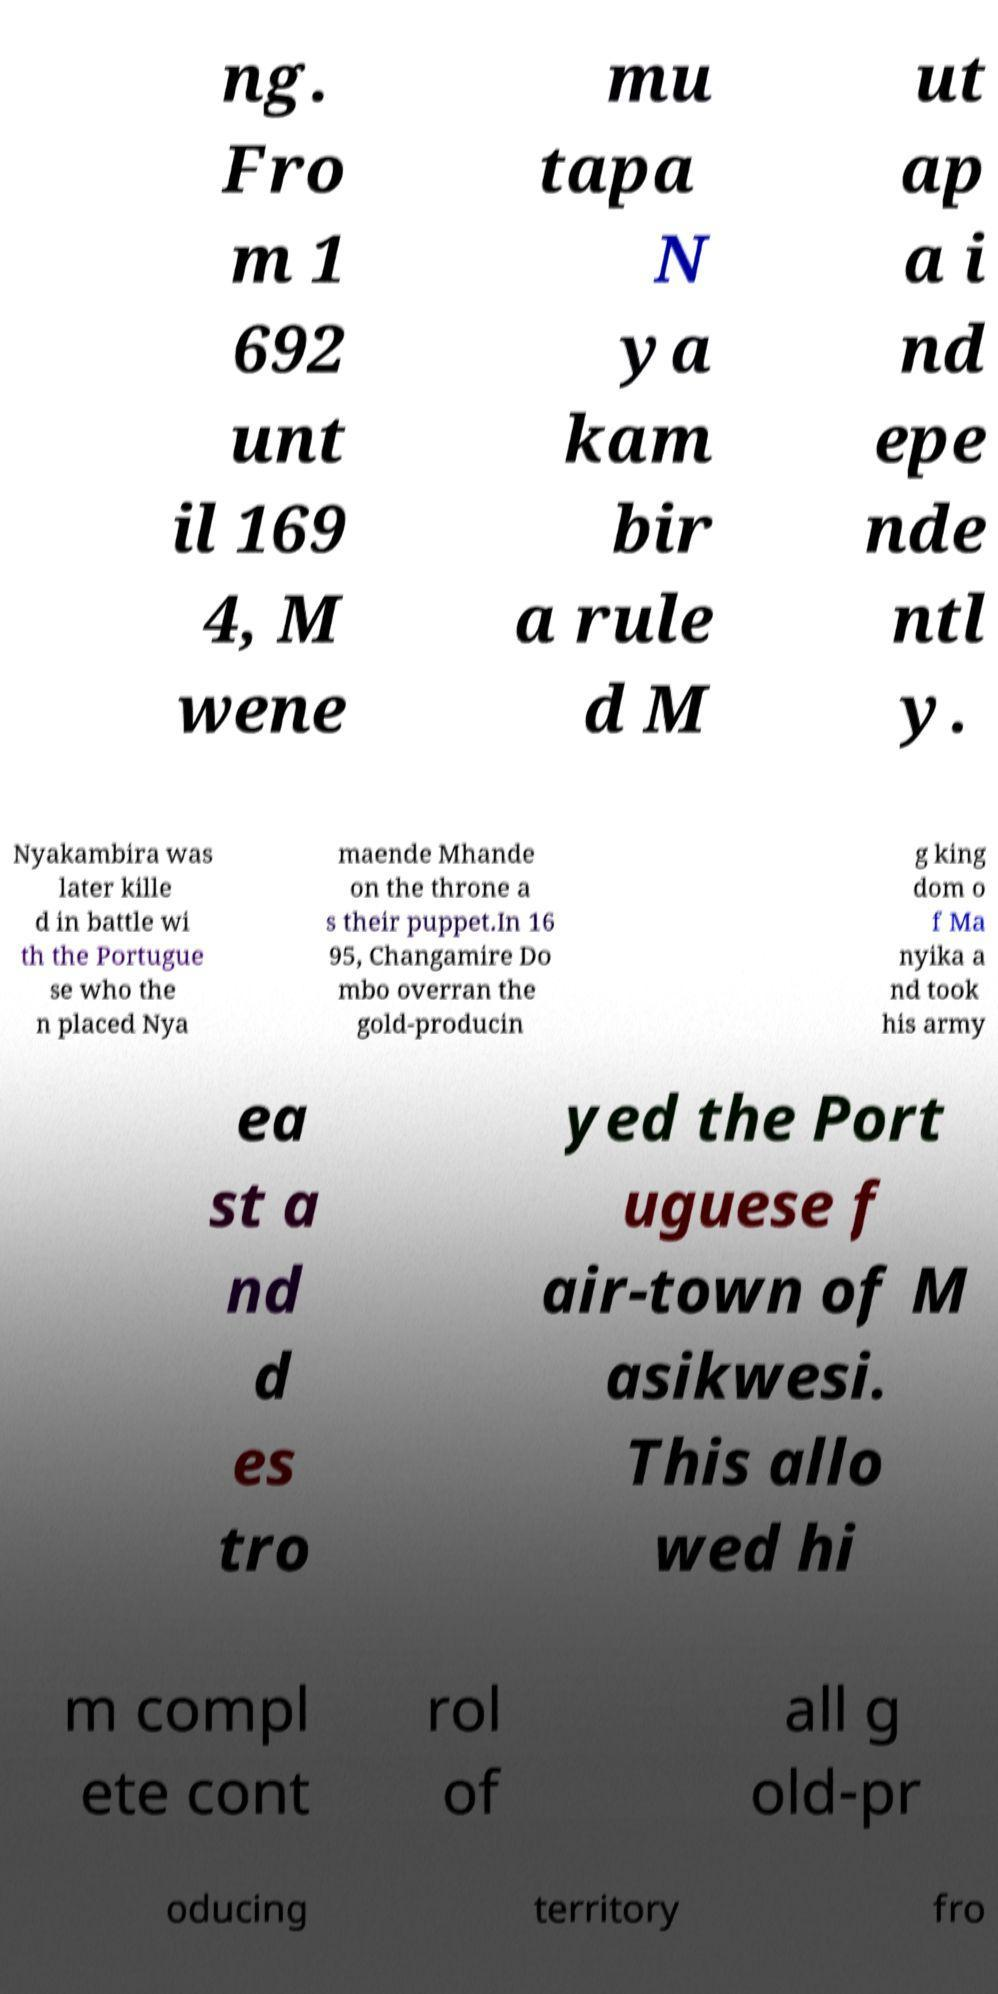Can you accurately transcribe the text from the provided image for me? ng. Fro m 1 692 unt il 169 4, M wene mu tapa N ya kam bir a rule d M ut ap a i nd epe nde ntl y. Nyakambira was later kille d in battle wi th the Portugue se who the n placed Nya maende Mhande on the throne a s their puppet.In 16 95, Changamire Do mbo overran the gold-producin g king dom o f Ma nyika a nd took his army ea st a nd d es tro yed the Port uguese f air-town of M asikwesi. This allo wed hi m compl ete cont rol of all g old-pr oducing territory fro 